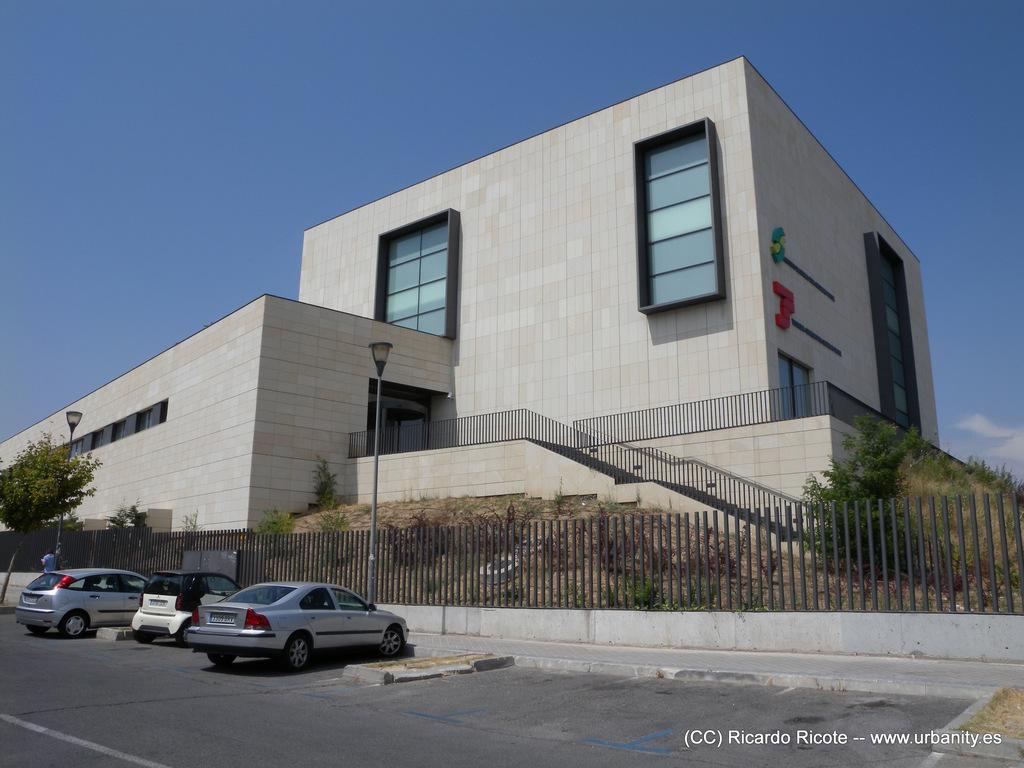In one or two sentences, can you explain what this image depicts? On the bottom right, there is a watermark. On the left side, there are vehicles parked on a road. In the background, there are trees, plants, poles, a building and the sky. 